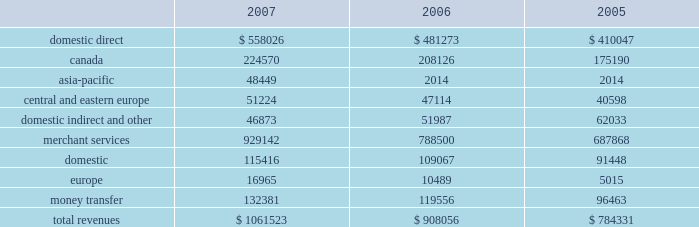Asia-pacific acquisition on july 24 , 2006 , we completed the purchase of a fifty-six percent ownership interest in the merchant acquiring business of the hongkong and shanghai banking corporation limited , or hsbc .
This business provides card payment processing services to merchants in the asia-pacific region .
The business includes hsbc 2019s payment processing operations in the following ten countries and territories : brunei , china , hong kong , india , macau , malaysia , maldives , singapore , sri lanka and taiwan .
Under the terms of the agreement , we initially paid hsbc $ 67.2 million in cash to acquire our ownership interest .
We paid an additional $ 1.4 million under this agreement during fiscal 2007 , for a total purchase price of $ 68.6 million to acquire our ownership interest .
In conjunction with this acquisition , we entered into a transition services agreement with hsbc that may be terminated at any time .
Under this agreement , we expect hsbc will continue to perform payment processing operations and related support services until we integrate these functions into our own operations , which we expect will be completed in 2010 .
The operating results of this acquisition are included in our consolidated statements of income from the date of the acquisition .
Business description we are a leading payment processing and consumer money transfer company .
As a high-volume processor of electronic transactions , we enable merchants , multinational corporations , financial institutions , consumers , government agencies and other profit and non-profit business enterprises to facilitate payments to purchase goods and services or further other economic goals .
Our role is to serve as an intermediary in the exchange of information and funds that must occur between parties so that a payment transaction or money transfer can be completed .
We were incorporated in georgia as global payments inc .
In september 2000 , and we spun-off from our former parent company on january 31 , 2001 .
Including our time as part of our former parent company , we have provided transaction processing services since 1967 .
We market our products and services throughout the united states , canada , europe and the asia-pacific region .
We operate in two business segments , merchant services and money transfer , and we offer various products through these segments .
Our merchant services segment targets customers in many vertical industries including financial institutions , gaming , government , health care , professional services , restaurants , retail , universities and utilities .
Our money transfer segment primarily targets immigrants in the united states and europe .
See note 10 in the notes to consolidated financial statements for additional segment information and 201citem 1a 2014risk factors 201d for a discussion of risks involved with our international operations .
Total revenues from our merchant services and money transfer segments , by geography and sales channel , are as follows ( amounts in thousands ) : .

What percent of total revenues was represented by merchant services in 2006? 
Computations: (788500 / 908056)
Answer: 0.86834. 